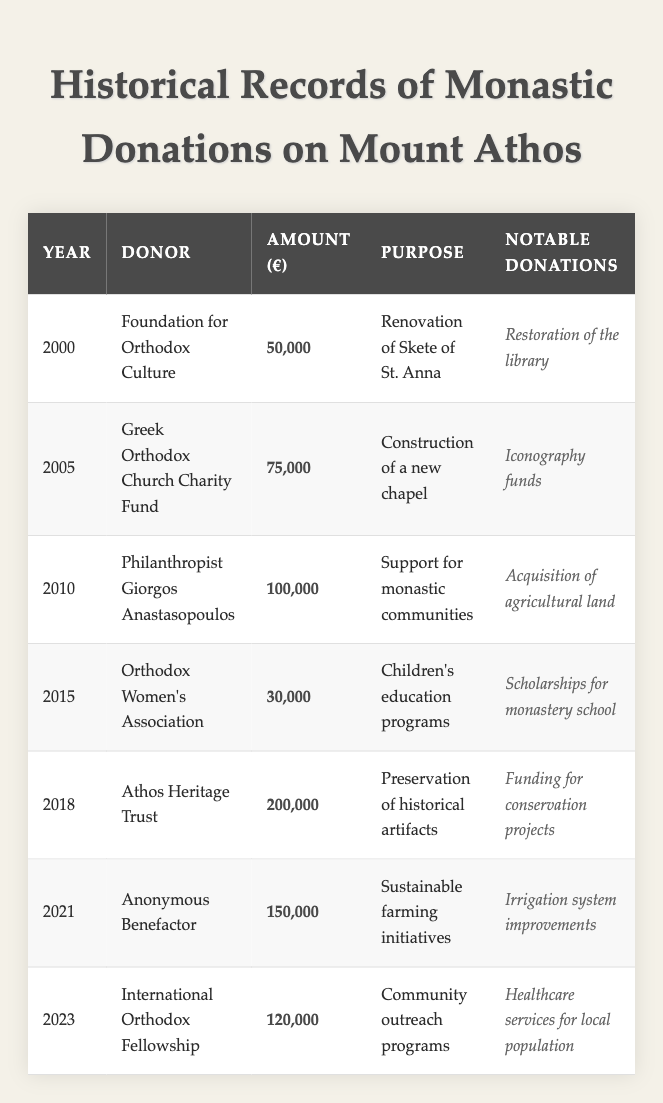What was the largest single donation amount according to the table? The highest donation amount in the table is 200,000 euros, which occurred in the year 2018.
Answer: 200,000 euros Who donated for the renovation of the Skete of St. Anna? The donation for the renovation of the Skete of St. Anna was made by the Foundation for Orthodox Culture.
Answer: Foundation for Orthodox Culture How many donations have been made in the years after 2015? The years after 2015 are 2016, 2017, 2018, 2019, 2020, 2021, 2022, and 2023; there are 4 donations in 2018, 2021, and 2023.
Answer: 4 donations What is the total amount of donations between 2010 and 2023? The total amount of donations from 2010 to 2023 is calculated by adding the contributions from 2010 (100,000), 2015 (30,000), 2018 (200,000), 2021 (150,000), and 2023 (120,000), which sums to 600,000 euros.
Answer: 600,000 euros Did any donor contribute towards educational programs? Yes, the Orthodox Women's Association contributed for children's education programs in 2015 with a donation of 30,000 euros.
Answer: Yes What can be inferred about the trend of monastic donations over the years? Analyzing the donation amounts, it can be inferred that the donations tend to increase over the years, with the highest contributions recorded in recent years, particularly in 2018 and 2021.
Answer: Increasing trend What is the average amount donated across all years listed in the table? The average donation is calculated by adding all the donation amounts (50,000 + 75,000 + 100,000 + 30,000 + 200,000 + 150,000 + 120,000 = 725,000 euros) and dividing it by the number of donations (7), which results in an average of approximately 103,571.43 euros.
Answer: 103,571.43 euros Has there been any anonymous donations? Yes, there was an anonymous donation made in 2021 for sustainable farming initiatives.
Answer: Yes Which donor contributed the least amount, and how much was it? The least amount was donated by the Orthodox Women's Association in 2015, totaling 30,000 euros.
Answer: 30,000 euros How many donations were made for purposes related to education? There is one donation related to education made by the Orthodox Women's Association in 2015.
Answer: 1 donation If we consider only 2021 and 2023, which year saw a higher donation amount? In 2021, the donation was 150,000 euros, while in 2023 it was 120,000 euros, meaning 2021 had the higher amount.
Answer: 2021 